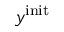Convert formula to latex. <formula><loc_0><loc_0><loc_500><loc_500>y ^ { i n i t }</formula> 